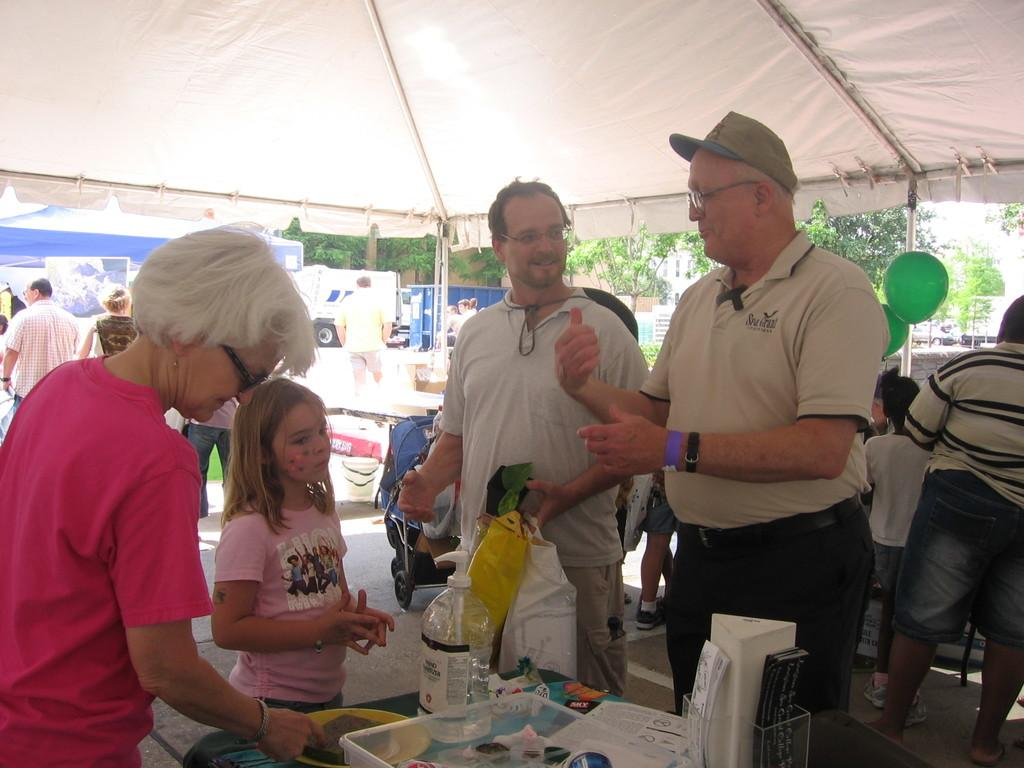What is located in the center of the image? In the center of the image, there are persons, a table, bottles, and a balloon. What is the setting for the objects and people in the center of the image? The center of the image is under a tent. What can be seen in the background of the image? In the background of the image, there is a tent, vehicles, persons, trees, buildings, and the sky. What is the governor's stance on the gun control issue in the image? There is no mention of a governor or gun control issue in the image. What is the tendency of the balloon in the image? The balloon is stationary in the image and does not exhibit any tendency to move or change position. 